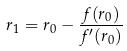Convert formula to latex. <formula><loc_0><loc_0><loc_500><loc_500>r _ { 1 } = r _ { 0 } - \frac { f ( r _ { 0 } ) } { f ^ { \prime } ( r _ { 0 } ) }</formula> 